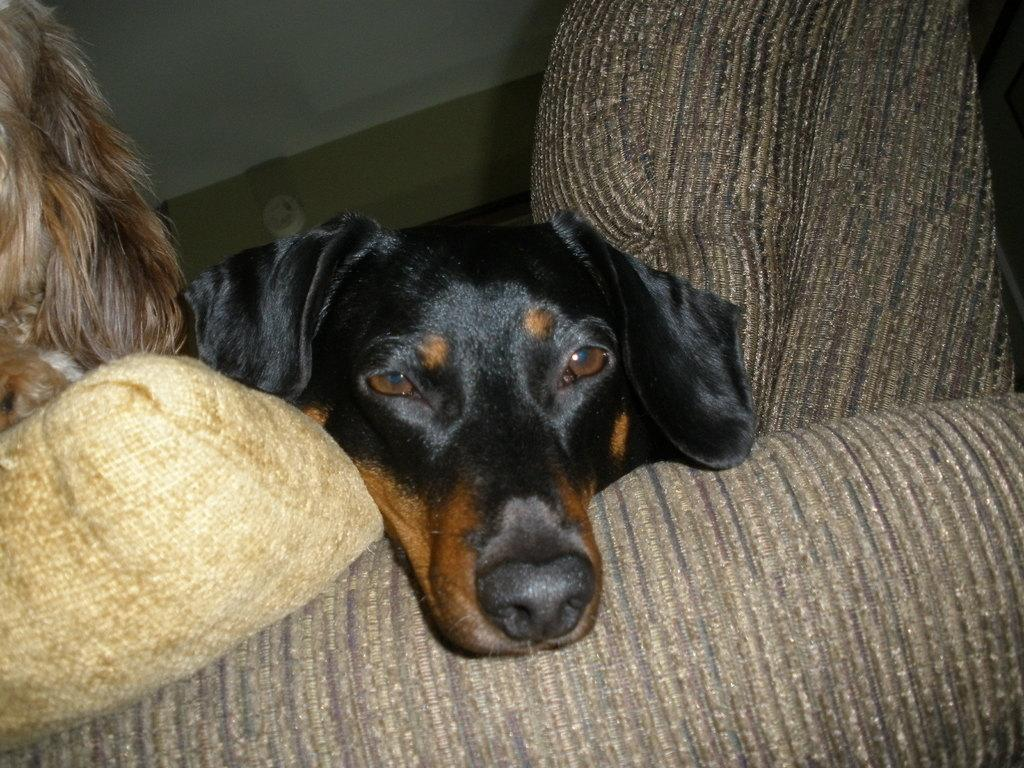What is the main subject of the image? The main subject of the image is a dog's face. What can be seen in the background of the image? There is a wall visible in the image. What is the rate at which the horses are running in the image? There are no horses present in the image, so it is not possible to determine their running rate. 